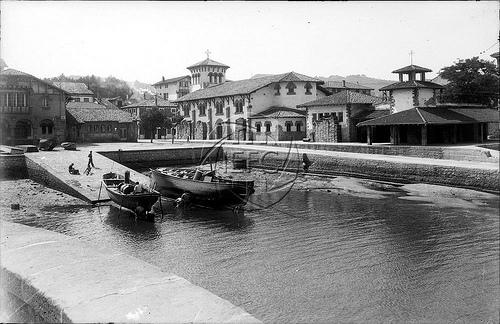Describe the natural elements present in the image. There is a clear sky above, the water has ripples, and there are green trees behind a building and on the street curb. Provide a brief description of the scene captured in the image. The black and white image showcases a canal scene with two boats, a few people, buildings, and a stone wall, all set against a clear sky backdrop. Mention the main elements of the image along with their locations in the scene. Two boats are on the water, with two people on a boat ramp nearby. There's a building with a cross on the roof, a stone wall next to the water, and a clear sky above. Provide a descriptive statement about the photograph that could be included in an art exhibition. This evocative black-and-white composition captures the tranquil beauty of a canal setting, where boats and architecture harmoniously coexist amidst nature's bounty. Describe the various architectural elements present in the image. There are buildings with archways, crosses on top of roofs, doorways, and windows. A brick wall and concrete ramp can also be seen near the water. Provide a poetic description of the image. A placid canal cradles two floating boats, while life stirs on the ramp and amongst the buildings, towering under the serene, cloudless sky. Using concise language, depict the main actions happening in the image. Two boats float on rippled water, men stand and sit on boat ramp, trees grow nearby, and a building with cross stands tall. Narrate the photograph as if describing it to a person who cannot see it. In this black and white picture, there's a peaceful scene with two boats on a canal. Nearby is a boat ramp where two people are present. There are buildings, trees, and a clear sky above. Describe the key components of the image as if writing for a travel blog. This vintage, monochromatic snapshot captures the charm of a canal scene, complete with quaint boats, historic buildings, and lush trees all under a pristine sky. Explain what a person might see if they were standing in the environment shown in the image. They would see two boats on calm waters, people on a boat ramp, a stone wall, buildings with unique architectural details, and a beautiful clear sky overhead. 